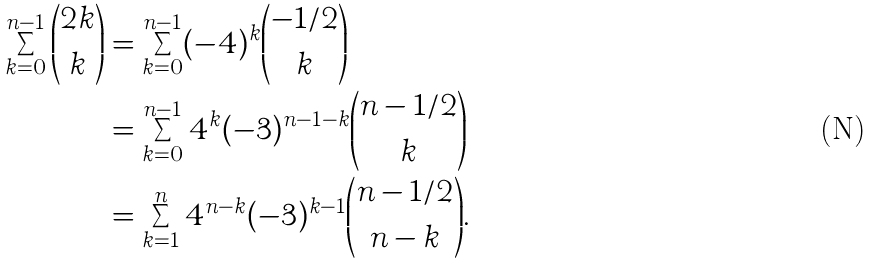<formula> <loc_0><loc_0><loc_500><loc_500>\sum _ { k = 0 } ^ { n - 1 } \binom { 2 k } { k } & = \sum _ { k = 0 } ^ { n - 1 } ( - 4 ) ^ { k } \binom { - 1 / 2 } { k } \\ & = \sum _ { k = 0 } ^ { n - 1 } 4 ^ { k } ( - 3 ) ^ { n - 1 - k } \binom { n - 1 / 2 } { k } \\ & = \sum _ { k = 1 } ^ { n } 4 ^ { n - k } ( - 3 ) ^ { k - 1 } \binom { n - 1 / 2 } { n - k } .</formula> 